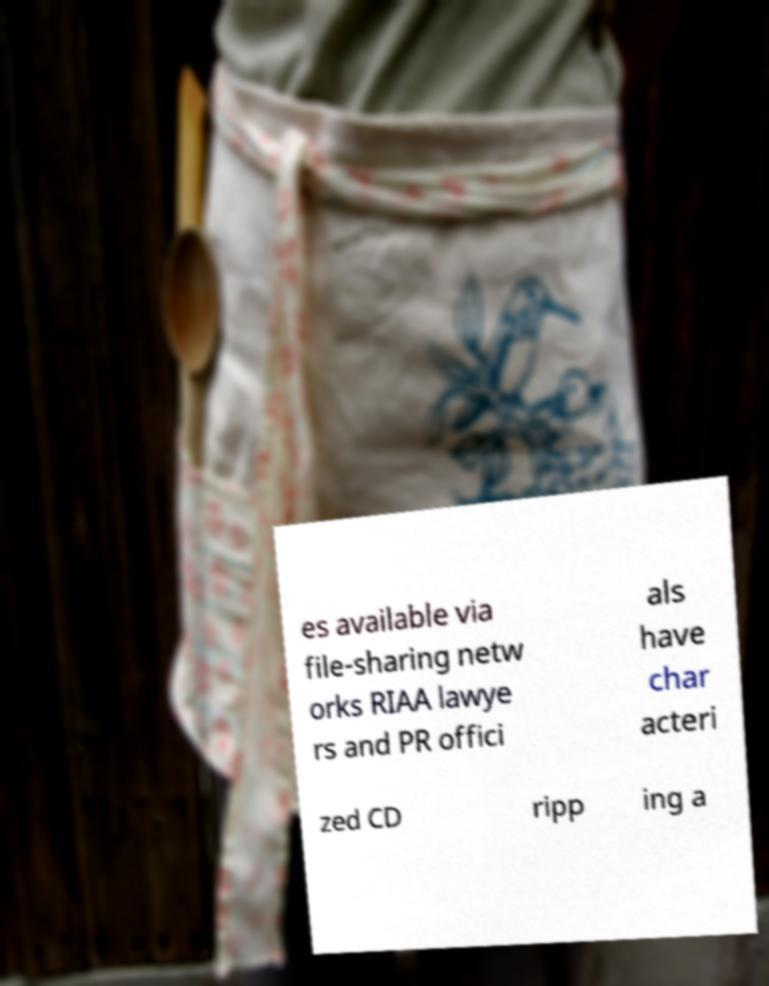Please identify and transcribe the text found in this image. es available via file-sharing netw orks RIAA lawye rs and PR offici als have char acteri zed CD ripp ing a 